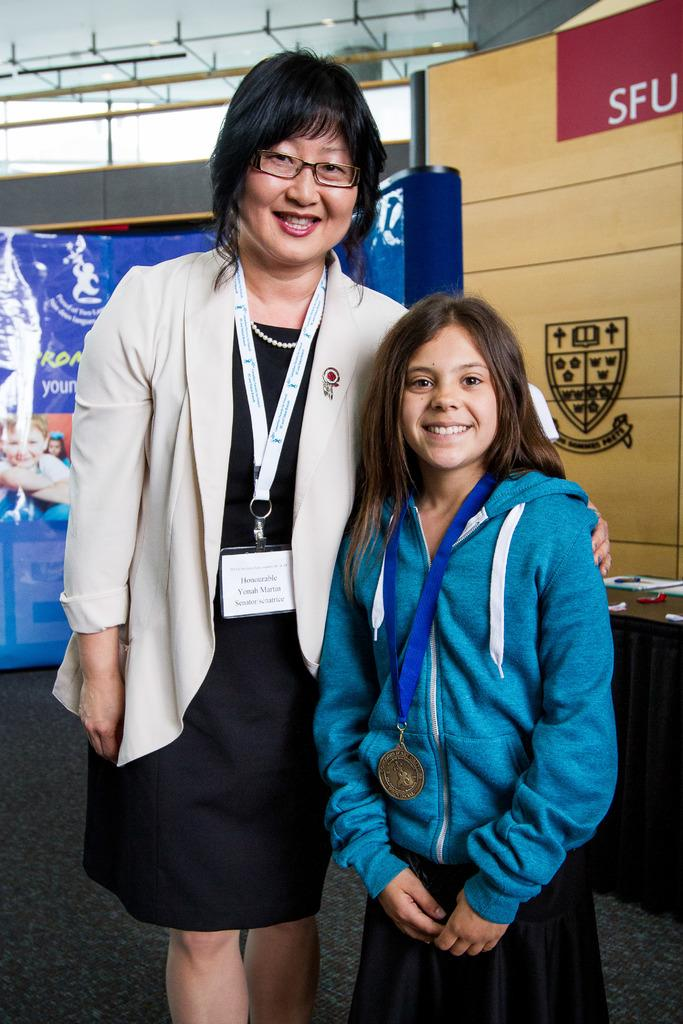How many people are in the image? There are two persons in the image. What is unique about the attire of each person? One person is wearing a tag, and the other person is wearing a medal. What can be seen hanging from the roof in the image? There are lights hanging from the roof in the image. What type of decorations are present in the image? There are banners visible in the image. What type of harmony can be heard in the background of the image? There is no audible sound or harmony present in the image; it is a still photograph. 